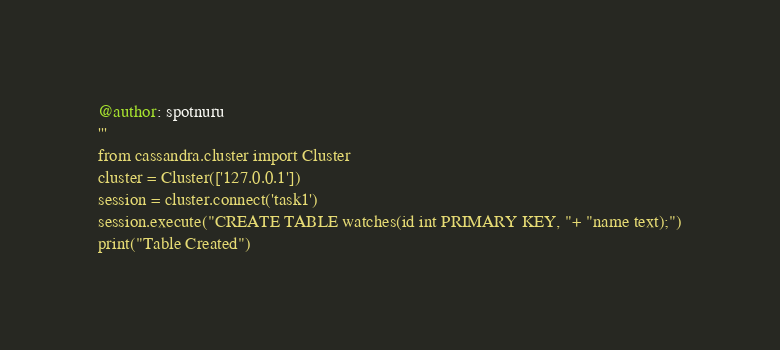<code> <loc_0><loc_0><loc_500><loc_500><_Python_>@author: spotnuru
'''
from cassandra.cluster import Cluster
cluster = Cluster(['127.0.0.1'])
session = cluster.connect('task1')
session.execute("CREATE TABLE watches(id int PRIMARY KEY, "+ "name text);")
print("Table Created")</code> 